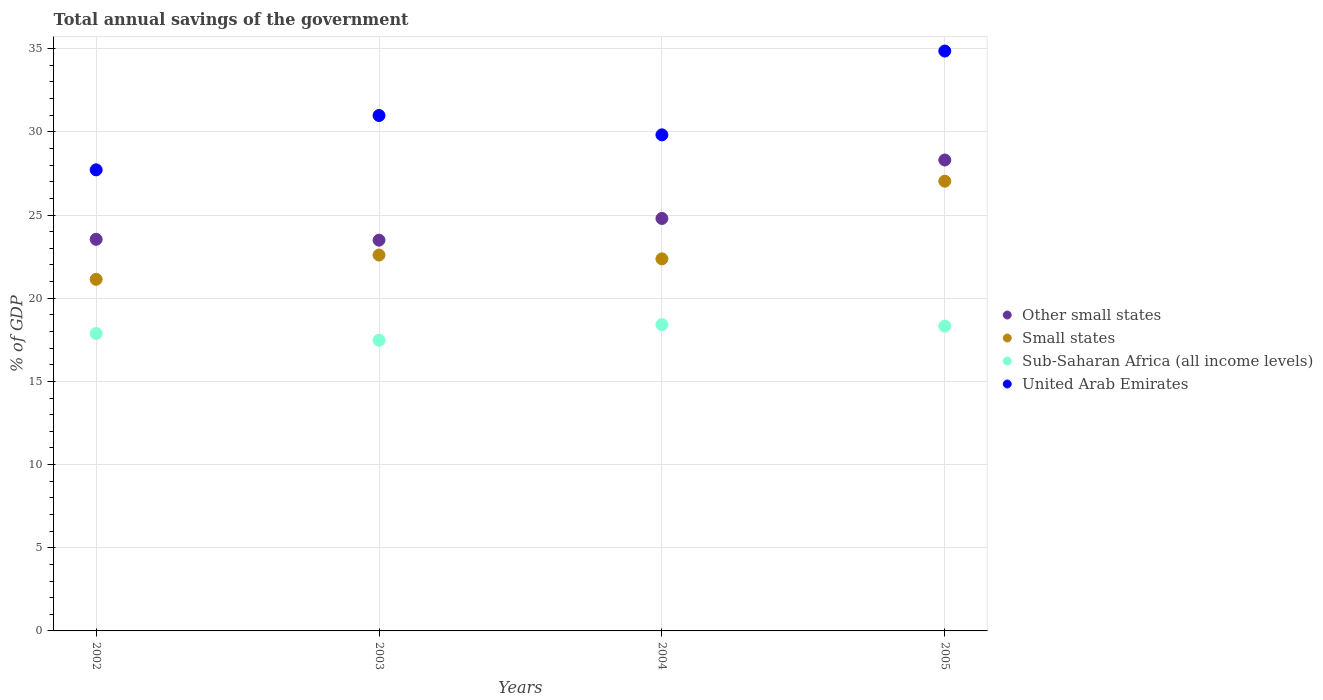Is the number of dotlines equal to the number of legend labels?
Your response must be concise. Yes. What is the total annual savings of the government in Small states in 2003?
Provide a succinct answer. 22.6. Across all years, what is the maximum total annual savings of the government in Small states?
Your answer should be compact. 27.04. Across all years, what is the minimum total annual savings of the government in Small states?
Ensure brevity in your answer.  21.14. In which year was the total annual savings of the government in Other small states maximum?
Offer a very short reply. 2005. In which year was the total annual savings of the government in United Arab Emirates minimum?
Ensure brevity in your answer.  2002. What is the total total annual savings of the government in Other small states in the graph?
Offer a very short reply. 100.14. What is the difference between the total annual savings of the government in Sub-Saharan Africa (all income levels) in 2002 and that in 2005?
Offer a very short reply. -0.44. What is the difference between the total annual savings of the government in Small states in 2004 and the total annual savings of the government in United Arab Emirates in 2005?
Your response must be concise. -12.49. What is the average total annual savings of the government in United Arab Emirates per year?
Offer a very short reply. 30.85. In the year 2005, what is the difference between the total annual savings of the government in Other small states and total annual savings of the government in Small states?
Your answer should be compact. 1.27. What is the ratio of the total annual savings of the government in Small states in 2004 to that in 2005?
Your answer should be very brief. 0.83. Is the difference between the total annual savings of the government in Other small states in 2002 and 2004 greater than the difference between the total annual savings of the government in Small states in 2002 and 2004?
Offer a terse response. No. What is the difference between the highest and the second highest total annual savings of the government in Small states?
Offer a terse response. 4.44. What is the difference between the highest and the lowest total annual savings of the government in Small states?
Provide a succinct answer. 5.9. Is it the case that in every year, the sum of the total annual savings of the government in United Arab Emirates and total annual savings of the government in Small states  is greater than the sum of total annual savings of the government in Sub-Saharan Africa (all income levels) and total annual savings of the government in Other small states?
Your answer should be very brief. Yes. Is the total annual savings of the government in Other small states strictly less than the total annual savings of the government in United Arab Emirates over the years?
Ensure brevity in your answer.  Yes. How many years are there in the graph?
Your answer should be very brief. 4. What is the difference between two consecutive major ticks on the Y-axis?
Your answer should be very brief. 5. Does the graph contain any zero values?
Your answer should be very brief. No. How are the legend labels stacked?
Offer a terse response. Vertical. What is the title of the graph?
Offer a terse response. Total annual savings of the government. Does "Uzbekistan" appear as one of the legend labels in the graph?
Ensure brevity in your answer.  No. What is the label or title of the X-axis?
Provide a short and direct response. Years. What is the label or title of the Y-axis?
Your answer should be compact. % of GDP. What is the % of GDP of Other small states in 2002?
Provide a short and direct response. 23.54. What is the % of GDP in Small states in 2002?
Your answer should be compact. 21.14. What is the % of GDP in Sub-Saharan Africa (all income levels) in 2002?
Provide a short and direct response. 17.88. What is the % of GDP in United Arab Emirates in 2002?
Ensure brevity in your answer.  27.72. What is the % of GDP of Other small states in 2003?
Your response must be concise. 23.49. What is the % of GDP in Small states in 2003?
Give a very brief answer. 22.6. What is the % of GDP in Sub-Saharan Africa (all income levels) in 2003?
Ensure brevity in your answer.  17.48. What is the % of GDP of United Arab Emirates in 2003?
Keep it short and to the point. 30.98. What is the % of GDP of Other small states in 2004?
Keep it short and to the point. 24.79. What is the % of GDP of Small states in 2004?
Make the answer very short. 22.37. What is the % of GDP of Sub-Saharan Africa (all income levels) in 2004?
Your answer should be very brief. 18.41. What is the % of GDP of United Arab Emirates in 2004?
Make the answer very short. 29.82. What is the % of GDP of Other small states in 2005?
Offer a very short reply. 28.31. What is the % of GDP in Small states in 2005?
Your answer should be compact. 27.04. What is the % of GDP of Sub-Saharan Africa (all income levels) in 2005?
Your answer should be compact. 18.32. What is the % of GDP in United Arab Emirates in 2005?
Keep it short and to the point. 34.86. Across all years, what is the maximum % of GDP of Other small states?
Keep it short and to the point. 28.31. Across all years, what is the maximum % of GDP in Small states?
Offer a very short reply. 27.04. Across all years, what is the maximum % of GDP of Sub-Saharan Africa (all income levels)?
Provide a succinct answer. 18.41. Across all years, what is the maximum % of GDP in United Arab Emirates?
Provide a short and direct response. 34.86. Across all years, what is the minimum % of GDP in Other small states?
Offer a terse response. 23.49. Across all years, what is the minimum % of GDP in Small states?
Make the answer very short. 21.14. Across all years, what is the minimum % of GDP of Sub-Saharan Africa (all income levels)?
Offer a very short reply. 17.48. Across all years, what is the minimum % of GDP of United Arab Emirates?
Provide a succinct answer. 27.72. What is the total % of GDP of Other small states in the graph?
Give a very brief answer. 100.14. What is the total % of GDP of Small states in the graph?
Ensure brevity in your answer.  93.13. What is the total % of GDP in Sub-Saharan Africa (all income levels) in the graph?
Offer a terse response. 72.09. What is the total % of GDP of United Arab Emirates in the graph?
Ensure brevity in your answer.  123.38. What is the difference between the % of GDP of Other small states in 2002 and that in 2003?
Your response must be concise. 0.05. What is the difference between the % of GDP of Small states in 2002 and that in 2003?
Keep it short and to the point. -1.46. What is the difference between the % of GDP in Sub-Saharan Africa (all income levels) in 2002 and that in 2003?
Provide a short and direct response. 0.4. What is the difference between the % of GDP of United Arab Emirates in 2002 and that in 2003?
Offer a terse response. -3.27. What is the difference between the % of GDP of Other small states in 2002 and that in 2004?
Make the answer very short. -1.25. What is the difference between the % of GDP of Small states in 2002 and that in 2004?
Offer a very short reply. -1.23. What is the difference between the % of GDP of Sub-Saharan Africa (all income levels) in 2002 and that in 2004?
Make the answer very short. -0.53. What is the difference between the % of GDP in United Arab Emirates in 2002 and that in 2004?
Keep it short and to the point. -2.1. What is the difference between the % of GDP in Other small states in 2002 and that in 2005?
Ensure brevity in your answer.  -4.77. What is the difference between the % of GDP in Small states in 2002 and that in 2005?
Your answer should be very brief. -5.9. What is the difference between the % of GDP in Sub-Saharan Africa (all income levels) in 2002 and that in 2005?
Your answer should be compact. -0.44. What is the difference between the % of GDP in United Arab Emirates in 2002 and that in 2005?
Your answer should be very brief. -7.14. What is the difference between the % of GDP of Other small states in 2003 and that in 2004?
Your answer should be compact. -1.3. What is the difference between the % of GDP in Small states in 2003 and that in 2004?
Provide a succinct answer. 0.23. What is the difference between the % of GDP of Sub-Saharan Africa (all income levels) in 2003 and that in 2004?
Make the answer very short. -0.94. What is the difference between the % of GDP of United Arab Emirates in 2003 and that in 2004?
Offer a terse response. 1.16. What is the difference between the % of GDP in Other small states in 2003 and that in 2005?
Provide a succinct answer. -4.82. What is the difference between the % of GDP in Small states in 2003 and that in 2005?
Provide a short and direct response. -4.44. What is the difference between the % of GDP in Sub-Saharan Africa (all income levels) in 2003 and that in 2005?
Provide a short and direct response. -0.85. What is the difference between the % of GDP of United Arab Emirates in 2003 and that in 2005?
Provide a short and direct response. -3.88. What is the difference between the % of GDP in Other small states in 2004 and that in 2005?
Offer a terse response. -3.51. What is the difference between the % of GDP of Small states in 2004 and that in 2005?
Your answer should be very brief. -4.67. What is the difference between the % of GDP in Sub-Saharan Africa (all income levels) in 2004 and that in 2005?
Your answer should be very brief. 0.09. What is the difference between the % of GDP in United Arab Emirates in 2004 and that in 2005?
Give a very brief answer. -5.04. What is the difference between the % of GDP of Other small states in 2002 and the % of GDP of Small states in 2003?
Make the answer very short. 0.95. What is the difference between the % of GDP in Other small states in 2002 and the % of GDP in Sub-Saharan Africa (all income levels) in 2003?
Your answer should be compact. 6.07. What is the difference between the % of GDP in Other small states in 2002 and the % of GDP in United Arab Emirates in 2003?
Your answer should be compact. -7.44. What is the difference between the % of GDP of Small states in 2002 and the % of GDP of Sub-Saharan Africa (all income levels) in 2003?
Make the answer very short. 3.66. What is the difference between the % of GDP of Small states in 2002 and the % of GDP of United Arab Emirates in 2003?
Your answer should be very brief. -9.85. What is the difference between the % of GDP in Sub-Saharan Africa (all income levels) in 2002 and the % of GDP in United Arab Emirates in 2003?
Offer a terse response. -13.1. What is the difference between the % of GDP of Other small states in 2002 and the % of GDP of Small states in 2004?
Give a very brief answer. 1.18. What is the difference between the % of GDP in Other small states in 2002 and the % of GDP in Sub-Saharan Africa (all income levels) in 2004?
Provide a succinct answer. 5.13. What is the difference between the % of GDP of Other small states in 2002 and the % of GDP of United Arab Emirates in 2004?
Offer a very short reply. -6.28. What is the difference between the % of GDP in Small states in 2002 and the % of GDP in Sub-Saharan Africa (all income levels) in 2004?
Offer a very short reply. 2.72. What is the difference between the % of GDP of Small states in 2002 and the % of GDP of United Arab Emirates in 2004?
Keep it short and to the point. -8.69. What is the difference between the % of GDP in Sub-Saharan Africa (all income levels) in 2002 and the % of GDP in United Arab Emirates in 2004?
Provide a short and direct response. -11.94. What is the difference between the % of GDP in Other small states in 2002 and the % of GDP in Small states in 2005?
Your answer should be very brief. -3.49. What is the difference between the % of GDP in Other small states in 2002 and the % of GDP in Sub-Saharan Africa (all income levels) in 2005?
Keep it short and to the point. 5.22. What is the difference between the % of GDP in Other small states in 2002 and the % of GDP in United Arab Emirates in 2005?
Provide a succinct answer. -11.32. What is the difference between the % of GDP of Small states in 2002 and the % of GDP of Sub-Saharan Africa (all income levels) in 2005?
Keep it short and to the point. 2.81. What is the difference between the % of GDP in Small states in 2002 and the % of GDP in United Arab Emirates in 2005?
Offer a very short reply. -13.72. What is the difference between the % of GDP in Sub-Saharan Africa (all income levels) in 2002 and the % of GDP in United Arab Emirates in 2005?
Provide a succinct answer. -16.98. What is the difference between the % of GDP in Other small states in 2003 and the % of GDP in Small states in 2004?
Ensure brevity in your answer.  1.12. What is the difference between the % of GDP of Other small states in 2003 and the % of GDP of Sub-Saharan Africa (all income levels) in 2004?
Offer a terse response. 5.08. What is the difference between the % of GDP of Other small states in 2003 and the % of GDP of United Arab Emirates in 2004?
Give a very brief answer. -6.33. What is the difference between the % of GDP in Small states in 2003 and the % of GDP in Sub-Saharan Africa (all income levels) in 2004?
Your answer should be compact. 4.18. What is the difference between the % of GDP in Small states in 2003 and the % of GDP in United Arab Emirates in 2004?
Provide a succinct answer. -7.23. What is the difference between the % of GDP in Sub-Saharan Africa (all income levels) in 2003 and the % of GDP in United Arab Emirates in 2004?
Keep it short and to the point. -12.35. What is the difference between the % of GDP of Other small states in 2003 and the % of GDP of Small states in 2005?
Provide a succinct answer. -3.54. What is the difference between the % of GDP in Other small states in 2003 and the % of GDP in Sub-Saharan Africa (all income levels) in 2005?
Your answer should be very brief. 5.17. What is the difference between the % of GDP in Other small states in 2003 and the % of GDP in United Arab Emirates in 2005?
Your response must be concise. -11.37. What is the difference between the % of GDP in Small states in 2003 and the % of GDP in Sub-Saharan Africa (all income levels) in 2005?
Offer a very short reply. 4.27. What is the difference between the % of GDP of Small states in 2003 and the % of GDP of United Arab Emirates in 2005?
Your response must be concise. -12.26. What is the difference between the % of GDP in Sub-Saharan Africa (all income levels) in 2003 and the % of GDP in United Arab Emirates in 2005?
Your response must be concise. -17.38. What is the difference between the % of GDP of Other small states in 2004 and the % of GDP of Small states in 2005?
Provide a short and direct response. -2.24. What is the difference between the % of GDP of Other small states in 2004 and the % of GDP of Sub-Saharan Africa (all income levels) in 2005?
Make the answer very short. 6.47. What is the difference between the % of GDP of Other small states in 2004 and the % of GDP of United Arab Emirates in 2005?
Provide a short and direct response. -10.06. What is the difference between the % of GDP in Small states in 2004 and the % of GDP in Sub-Saharan Africa (all income levels) in 2005?
Offer a terse response. 4.04. What is the difference between the % of GDP of Small states in 2004 and the % of GDP of United Arab Emirates in 2005?
Give a very brief answer. -12.49. What is the difference between the % of GDP in Sub-Saharan Africa (all income levels) in 2004 and the % of GDP in United Arab Emirates in 2005?
Your response must be concise. -16.45. What is the average % of GDP of Other small states per year?
Provide a succinct answer. 25.03. What is the average % of GDP of Small states per year?
Provide a short and direct response. 23.28. What is the average % of GDP of Sub-Saharan Africa (all income levels) per year?
Your answer should be very brief. 18.02. What is the average % of GDP of United Arab Emirates per year?
Your answer should be very brief. 30.85. In the year 2002, what is the difference between the % of GDP in Other small states and % of GDP in Small states?
Offer a terse response. 2.41. In the year 2002, what is the difference between the % of GDP of Other small states and % of GDP of Sub-Saharan Africa (all income levels)?
Offer a very short reply. 5.66. In the year 2002, what is the difference between the % of GDP of Other small states and % of GDP of United Arab Emirates?
Provide a short and direct response. -4.18. In the year 2002, what is the difference between the % of GDP in Small states and % of GDP in Sub-Saharan Africa (all income levels)?
Give a very brief answer. 3.26. In the year 2002, what is the difference between the % of GDP in Small states and % of GDP in United Arab Emirates?
Your answer should be very brief. -6.58. In the year 2002, what is the difference between the % of GDP in Sub-Saharan Africa (all income levels) and % of GDP in United Arab Emirates?
Provide a succinct answer. -9.84. In the year 2003, what is the difference between the % of GDP of Other small states and % of GDP of Small states?
Provide a short and direct response. 0.89. In the year 2003, what is the difference between the % of GDP in Other small states and % of GDP in Sub-Saharan Africa (all income levels)?
Your answer should be compact. 6.02. In the year 2003, what is the difference between the % of GDP in Other small states and % of GDP in United Arab Emirates?
Provide a short and direct response. -7.49. In the year 2003, what is the difference between the % of GDP of Small states and % of GDP of Sub-Saharan Africa (all income levels)?
Your response must be concise. 5.12. In the year 2003, what is the difference between the % of GDP of Small states and % of GDP of United Arab Emirates?
Offer a very short reply. -8.39. In the year 2003, what is the difference between the % of GDP in Sub-Saharan Africa (all income levels) and % of GDP in United Arab Emirates?
Your answer should be compact. -13.51. In the year 2004, what is the difference between the % of GDP of Other small states and % of GDP of Small states?
Provide a short and direct response. 2.43. In the year 2004, what is the difference between the % of GDP in Other small states and % of GDP in Sub-Saharan Africa (all income levels)?
Make the answer very short. 6.38. In the year 2004, what is the difference between the % of GDP in Other small states and % of GDP in United Arab Emirates?
Give a very brief answer. -5.03. In the year 2004, what is the difference between the % of GDP in Small states and % of GDP in Sub-Saharan Africa (all income levels)?
Provide a short and direct response. 3.95. In the year 2004, what is the difference between the % of GDP of Small states and % of GDP of United Arab Emirates?
Offer a terse response. -7.46. In the year 2004, what is the difference between the % of GDP in Sub-Saharan Africa (all income levels) and % of GDP in United Arab Emirates?
Offer a very short reply. -11.41. In the year 2005, what is the difference between the % of GDP in Other small states and % of GDP in Small states?
Your answer should be compact. 1.27. In the year 2005, what is the difference between the % of GDP of Other small states and % of GDP of Sub-Saharan Africa (all income levels)?
Your answer should be very brief. 9.99. In the year 2005, what is the difference between the % of GDP in Other small states and % of GDP in United Arab Emirates?
Your response must be concise. -6.55. In the year 2005, what is the difference between the % of GDP of Small states and % of GDP of Sub-Saharan Africa (all income levels)?
Your answer should be very brief. 8.71. In the year 2005, what is the difference between the % of GDP in Small states and % of GDP in United Arab Emirates?
Keep it short and to the point. -7.82. In the year 2005, what is the difference between the % of GDP of Sub-Saharan Africa (all income levels) and % of GDP of United Arab Emirates?
Ensure brevity in your answer.  -16.54. What is the ratio of the % of GDP in Small states in 2002 to that in 2003?
Your answer should be very brief. 0.94. What is the ratio of the % of GDP of Sub-Saharan Africa (all income levels) in 2002 to that in 2003?
Offer a terse response. 1.02. What is the ratio of the % of GDP in United Arab Emirates in 2002 to that in 2003?
Offer a terse response. 0.89. What is the ratio of the % of GDP in Other small states in 2002 to that in 2004?
Your response must be concise. 0.95. What is the ratio of the % of GDP of Small states in 2002 to that in 2004?
Offer a terse response. 0.94. What is the ratio of the % of GDP in Sub-Saharan Africa (all income levels) in 2002 to that in 2004?
Your answer should be very brief. 0.97. What is the ratio of the % of GDP in United Arab Emirates in 2002 to that in 2004?
Offer a very short reply. 0.93. What is the ratio of the % of GDP in Other small states in 2002 to that in 2005?
Your answer should be compact. 0.83. What is the ratio of the % of GDP in Small states in 2002 to that in 2005?
Offer a terse response. 0.78. What is the ratio of the % of GDP of Sub-Saharan Africa (all income levels) in 2002 to that in 2005?
Provide a short and direct response. 0.98. What is the ratio of the % of GDP in United Arab Emirates in 2002 to that in 2005?
Keep it short and to the point. 0.8. What is the ratio of the % of GDP in Small states in 2003 to that in 2004?
Make the answer very short. 1.01. What is the ratio of the % of GDP of Sub-Saharan Africa (all income levels) in 2003 to that in 2004?
Make the answer very short. 0.95. What is the ratio of the % of GDP in United Arab Emirates in 2003 to that in 2004?
Make the answer very short. 1.04. What is the ratio of the % of GDP of Other small states in 2003 to that in 2005?
Keep it short and to the point. 0.83. What is the ratio of the % of GDP of Small states in 2003 to that in 2005?
Make the answer very short. 0.84. What is the ratio of the % of GDP in Sub-Saharan Africa (all income levels) in 2003 to that in 2005?
Offer a terse response. 0.95. What is the ratio of the % of GDP in United Arab Emirates in 2003 to that in 2005?
Your response must be concise. 0.89. What is the ratio of the % of GDP in Other small states in 2004 to that in 2005?
Offer a terse response. 0.88. What is the ratio of the % of GDP in Small states in 2004 to that in 2005?
Offer a very short reply. 0.83. What is the ratio of the % of GDP in Sub-Saharan Africa (all income levels) in 2004 to that in 2005?
Ensure brevity in your answer.  1. What is the ratio of the % of GDP of United Arab Emirates in 2004 to that in 2005?
Keep it short and to the point. 0.86. What is the difference between the highest and the second highest % of GDP in Other small states?
Give a very brief answer. 3.51. What is the difference between the highest and the second highest % of GDP in Small states?
Keep it short and to the point. 4.44. What is the difference between the highest and the second highest % of GDP of Sub-Saharan Africa (all income levels)?
Provide a succinct answer. 0.09. What is the difference between the highest and the second highest % of GDP of United Arab Emirates?
Your response must be concise. 3.88. What is the difference between the highest and the lowest % of GDP in Other small states?
Keep it short and to the point. 4.82. What is the difference between the highest and the lowest % of GDP in Small states?
Provide a succinct answer. 5.9. What is the difference between the highest and the lowest % of GDP of Sub-Saharan Africa (all income levels)?
Ensure brevity in your answer.  0.94. What is the difference between the highest and the lowest % of GDP of United Arab Emirates?
Ensure brevity in your answer.  7.14. 